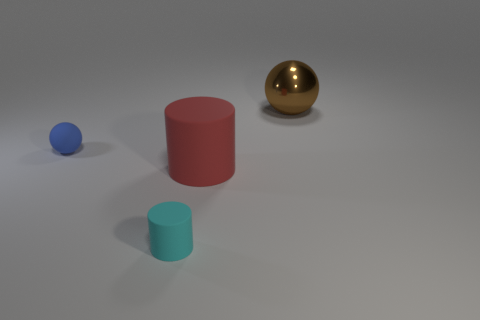Add 2 big green blocks. How many objects exist? 6 Add 4 small rubber things. How many small rubber things exist? 6 Subtract 0 blue cylinders. How many objects are left? 4 Subtract all brown shiny things. Subtract all large cyan shiny cubes. How many objects are left? 3 Add 3 small cyan things. How many small cyan things are left? 4 